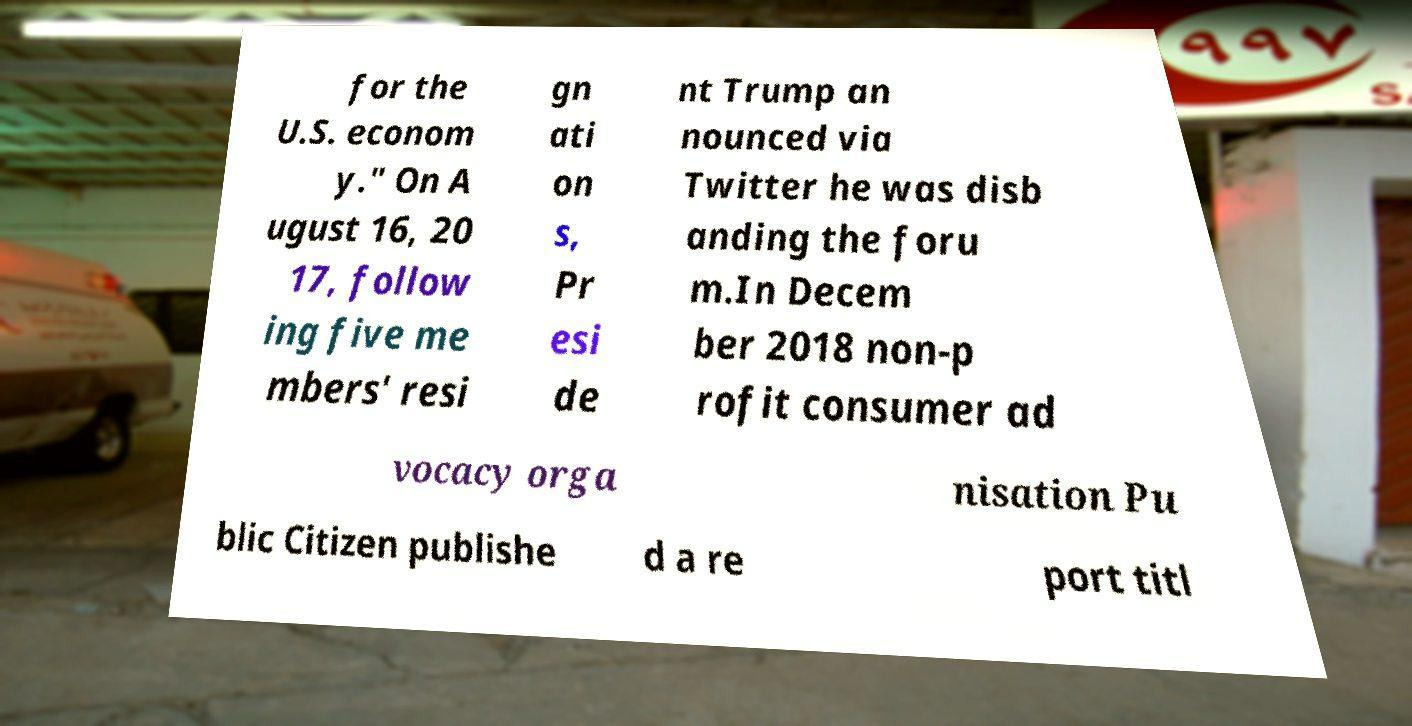Could you extract and type out the text from this image? for the U.S. econom y." On A ugust 16, 20 17, follow ing five me mbers' resi gn ati on s, Pr esi de nt Trump an nounced via Twitter he was disb anding the foru m.In Decem ber 2018 non-p rofit consumer ad vocacy orga nisation Pu blic Citizen publishe d a re port titl 